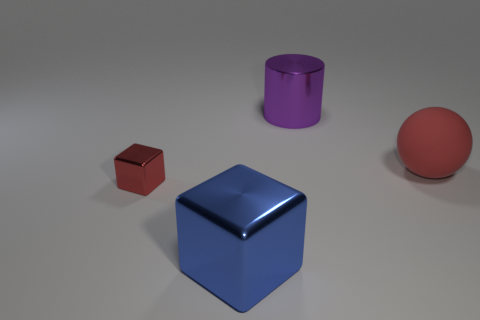How many small cubes are there? The image shows various geometric objects. Focusing on the size, the red cube qualifies as a 'small' cube due to its relative size compared to the other objects — notably smaller than the large blue cube beside it. Therefore, counting only the small-sized cubes, there is one small red cube in the image. 